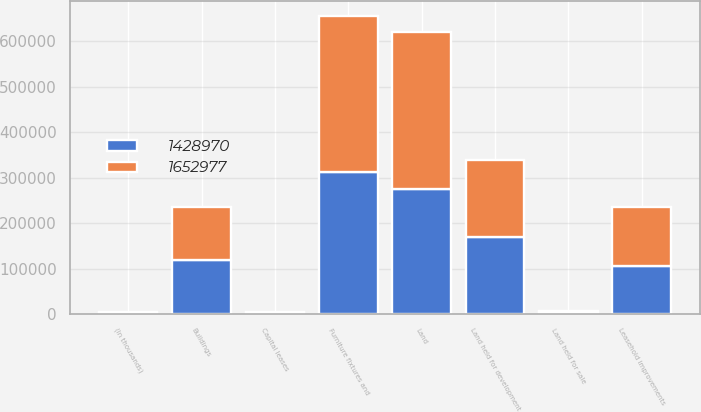<chart> <loc_0><loc_0><loc_500><loc_500><stacked_bar_chart><ecel><fcel>(In thousands)<fcel>Land<fcel>Land held for sale<fcel>Land held for development<fcel>Buildings<fcel>Capital leases<fcel>Leasehold improvements<fcel>Furniture fixtures and<nl><fcel>1.65298e+06<fcel>2014<fcel>346518<fcel>1050<fcel>170387<fcel>117940<fcel>1739<fcel>129186<fcel>343958<nl><fcel>1.42897e+06<fcel>2013<fcel>275060<fcel>4872<fcel>168830<fcel>117940<fcel>1739<fcel>106695<fcel>311646<nl></chart> 